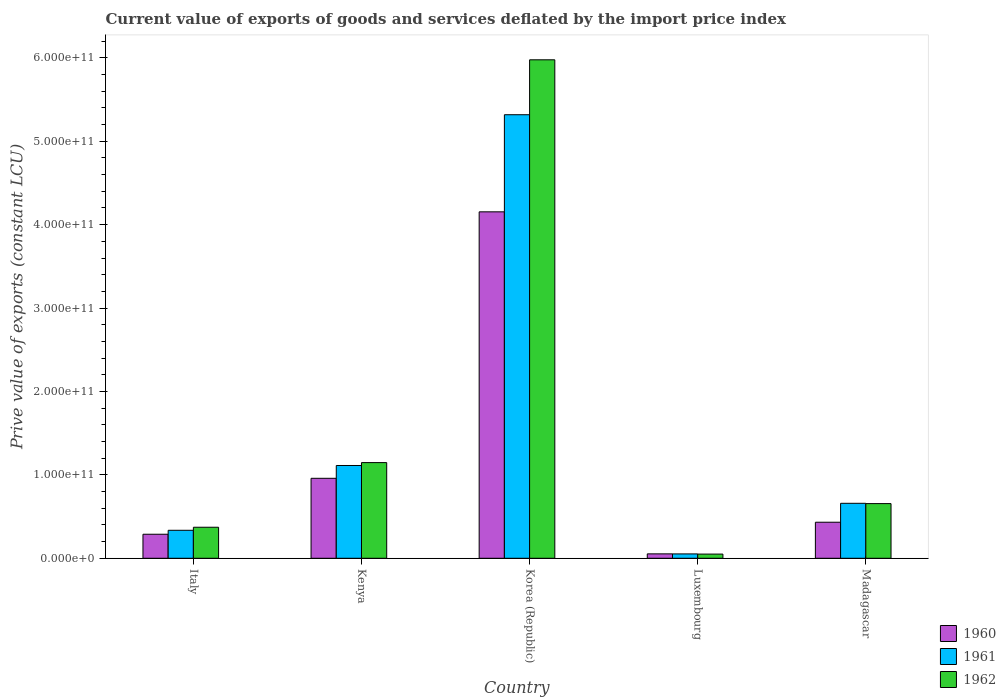How many groups of bars are there?
Offer a terse response. 5. Are the number of bars per tick equal to the number of legend labels?
Ensure brevity in your answer.  Yes. Are the number of bars on each tick of the X-axis equal?
Keep it short and to the point. Yes. How many bars are there on the 2nd tick from the left?
Make the answer very short. 3. How many bars are there on the 2nd tick from the right?
Your answer should be compact. 3. In how many cases, is the number of bars for a given country not equal to the number of legend labels?
Provide a short and direct response. 0. What is the prive value of exports in 1960 in Korea (Republic)?
Make the answer very short. 4.15e+11. Across all countries, what is the maximum prive value of exports in 1960?
Your answer should be compact. 4.15e+11. Across all countries, what is the minimum prive value of exports in 1962?
Give a very brief answer. 5.02e+09. In which country was the prive value of exports in 1961 minimum?
Keep it short and to the point. Luxembourg. What is the total prive value of exports in 1962 in the graph?
Make the answer very short. 8.20e+11. What is the difference between the prive value of exports in 1962 in Italy and that in Kenya?
Your answer should be very brief. -7.75e+1. What is the difference between the prive value of exports in 1960 in Korea (Republic) and the prive value of exports in 1962 in Kenya?
Offer a very short reply. 3.01e+11. What is the average prive value of exports in 1962 per country?
Provide a short and direct response. 1.64e+11. What is the difference between the prive value of exports of/in 1962 and prive value of exports of/in 1961 in Italy?
Provide a short and direct response. 3.65e+09. What is the ratio of the prive value of exports in 1962 in Italy to that in Korea (Republic)?
Offer a terse response. 0.06. What is the difference between the highest and the second highest prive value of exports in 1962?
Offer a terse response. -4.92e+1. What is the difference between the highest and the lowest prive value of exports in 1962?
Provide a short and direct response. 5.93e+11. In how many countries, is the prive value of exports in 1962 greater than the average prive value of exports in 1962 taken over all countries?
Your response must be concise. 1. Is the sum of the prive value of exports in 1961 in Italy and Korea (Republic) greater than the maximum prive value of exports in 1960 across all countries?
Keep it short and to the point. Yes. What does the 2nd bar from the right in Luxembourg represents?
Your answer should be compact. 1961. What is the difference between two consecutive major ticks on the Y-axis?
Give a very brief answer. 1.00e+11. Does the graph contain any zero values?
Ensure brevity in your answer.  No. How many legend labels are there?
Provide a short and direct response. 3. What is the title of the graph?
Offer a very short reply. Current value of exports of goods and services deflated by the import price index. What is the label or title of the X-axis?
Ensure brevity in your answer.  Country. What is the label or title of the Y-axis?
Your answer should be compact. Prive value of exports (constant LCU). What is the Prive value of exports (constant LCU) of 1960 in Italy?
Keep it short and to the point. 2.88e+1. What is the Prive value of exports (constant LCU) of 1961 in Italy?
Offer a terse response. 3.35e+1. What is the Prive value of exports (constant LCU) of 1962 in Italy?
Your answer should be compact. 3.72e+1. What is the Prive value of exports (constant LCU) of 1960 in Kenya?
Your answer should be compact. 9.59e+1. What is the Prive value of exports (constant LCU) in 1961 in Kenya?
Offer a very short reply. 1.11e+11. What is the Prive value of exports (constant LCU) in 1962 in Kenya?
Keep it short and to the point. 1.15e+11. What is the Prive value of exports (constant LCU) of 1960 in Korea (Republic)?
Make the answer very short. 4.15e+11. What is the Prive value of exports (constant LCU) in 1961 in Korea (Republic)?
Offer a very short reply. 5.32e+11. What is the Prive value of exports (constant LCU) in 1962 in Korea (Republic)?
Offer a very short reply. 5.98e+11. What is the Prive value of exports (constant LCU) of 1960 in Luxembourg?
Your response must be concise. 5.28e+09. What is the Prive value of exports (constant LCU) in 1961 in Luxembourg?
Offer a terse response. 5.22e+09. What is the Prive value of exports (constant LCU) in 1962 in Luxembourg?
Provide a short and direct response. 5.02e+09. What is the Prive value of exports (constant LCU) of 1960 in Madagascar?
Give a very brief answer. 4.32e+1. What is the Prive value of exports (constant LCU) of 1961 in Madagascar?
Provide a succinct answer. 6.59e+1. What is the Prive value of exports (constant LCU) in 1962 in Madagascar?
Give a very brief answer. 6.55e+1. Across all countries, what is the maximum Prive value of exports (constant LCU) of 1960?
Offer a terse response. 4.15e+11. Across all countries, what is the maximum Prive value of exports (constant LCU) of 1961?
Make the answer very short. 5.32e+11. Across all countries, what is the maximum Prive value of exports (constant LCU) in 1962?
Give a very brief answer. 5.98e+11. Across all countries, what is the minimum Prive value of exports (constant LCU) in 1960?
Your response must be concise. 5.28e+09. Across all countries, what is the minimum Prive value of exports (constant LCU) of 1961?
Provide a short and direct response. 5.22e+09. Across all countries, what is the minimum Prive value of exports (constant LCU) of 1962?
Provide a succinct answer. 5.02e+09. What is the total Prive value of exports (constant LCU) of 1960 in the graph?
Ensure brevity in your answer.  5.89e+11. What is the total Prive value of exports (constant LCU) of 1961 in the graph?
Your answer should be compact. 7.48e+11. What is the total Prive value of exports (constant LCU) of 1962 in the graph?
Your answer should be very brief. 8.20e+11. What is the difference between the Prive value of exports (constant LCU) of 1960 in Italy and that in Kenya?
Offer a very short reply. -6.71e+1. What is the difference between the Prive value of exports (constant LCU) in 1961 in Italy and that in Kenya?
Make the answer very short. -7.77e+1. What is the difference between the Prive value of exports (constant LCU) in 1962 in Italy and that in Kenya?
Keep it short and to the point. -7.75e+1. What is the difference between the Prive value of exports (constant LCU) in 1960 in Italy and that in Korea (Republic)?
Ensure brevity in your answer.  -3.87e+11. What is the difference between the Prive value of exports (constant LCU) of 1961 in Italy and that in Korea (Republic)?
Offer a terse response. -4.98e+11. What is the difference between the Prive value of exports (constant LCU) in 1962 in Italy and that in Korea (Republic)?
Your answer should be very brief. -5.60e+11. What is the difference between the Prive value of exports (constant LCU) in 1960 in Italy and that in Luxembourg?
Offer a very short reply. 2.35e+1. What is the difference between the Prive value of exports (constant LCU) of 1961 in Italy and that in Luxembourg?
Your answer should be very brief. 2.83e+1. What is the difference between the Prive value of exports (constant LCU) of 1962 in Italy and that in Luxembourg?
Ensure brevity in your answer.  3.22e+1. What is the difference between the Prive value of exports (constant LCU) in 1960 in Italy and that in Madagascar?
Your response must be concise. -1.44e+1. What is the difference between the Prive value of exports (constant LCU) of 1961 in Italy and that in Madagascar?
Your answer should be very brief. -3.24e+1. What is the difference between the Prive value of exports (constant LCU) in 1962 in Italy and that in Madagascar?
Give a very brief answer. -2.84e+1. What is the difference between the Prive value of exports (constant LCU) in 1960 in Kenya and that in Korea (Republic)?
Offer a very short reply. -3.19e+11. What is the difference between the Prive value of exports (constant LCU) in 1961 in Kenya and that in Korea (Republic)?
Your answer should be compact. -4.21e+11. What is the difference between the Prive value of exports (constant LCU) in 1962 in Kenya and that in Korea (Republic)?
Provide a succinct answer. -4.83e+11. What is the difference between the Prive value of exports (constant LCU) in 1960 in Kenya and that in Luxembourg?
Your answer should be very brief. 9.06e+1. What is the difference between the Prive value of exports (constant LCU) of 1961 in Kenya and that in Luxembourg?
Your answer should be very brief. 1.06e+11. What is the difference between the Prive value of exports (constant LCU) in 1962 in Kenya and that in Luxembourg?
Your response must be concise. 1.10e+11. What is the difference between the Prive value of exports (constant LCU) in 1960 in Kenya and that in Madagascar?
Make the answer very short. 5.27e+1. What is the difference between the Prive value of exports (constant LCU) in 1961 in Kenya and that in Madagascar?
Your answer should be compact. 4.53e+1. What is the difference between the Prive value of exports (constant LCU) in 1962 in Kenya and that in Madagascar?
Ensure brevity in your answer.  4.92e+1. What is the difference between the Prive value of exports (constant LCU) of 1960 in Korea (Republic) and that in Luxembourg?
Your answer should be compact. 4.10e+11. What is the difference between the Prive value of exports (constant LCU) in 1961 in Korea (Republic) and that in Luxembourg?
Your response must be concise. 5.27e+11. What is the difference between the Prive value of exports (constant LCU) in 1962 in Korea (Republic) and that in Luxembourg?
Offer a terse response. 5.93e+11. What is the difference between the Prive value of exports (constant LCU) in 1960 in Korea (Republic) and that in Madagascar?
Provide a succinct answer. 3.72e+11. What is the difference between the Prive value of exports (constant LCU) of 1961 in Korea (Republic) and that in Madagascar?
Offer a very short reply. 4.66e+11. What is the difference between the Prive value of exports (constant LCU) of 1962 in Korea (Republic) and that in Madagascar?
Offer a terse response. 5.32e+11. What is the difference between the Prive value of exports (constant LCU) in 1960 in Luxembourg and that in Madagascar?
Your response must be concise. -3.79e+1. What is the difference between the Prive value of exports (constant LCU) of 1961 in Luxembourg and that in Madagascar?
Your response must be concise. -6.07e+1. What is the difference between the Prive value of exports (constant LCU) in 1962 in Luxembourg and that in Madagascar?
Ensure brevity in your answer.  -6.05e+1. What is the difference between the Prive value of exports (constant LCU) of 1960 in Italy and the Prive value of exports (constant LCU) of 1961 in Kenya?
Keep it short and to the point. -8.24e+1. What is the difference between the Prive value of exports (constant LCU) of 1960 in Italy and the Prive value of exports (constant LCU) of 1962 in Kenya?
Your answer should be very brief. -8.59e+1. What is the difference between the Prive value of exports (constant LCU) of 1961 in Italy and the Prive value of exports (constant LCU) of 1962 in Kenya?
Your response must be concise. -8.12e+1. What is the difference between the Prive value of exports (constant LCU) in 1960 in Italy and the Prive value of exports (constant LCU) in 1961 in Korea (Republic)?
Ensure brevity in your answer.  -5.03e+11. What is the difference between the Prive value of exports (constant LCU) in 1960 in Italy and the Prive value of exports (constant LCU) in 1962 in Korea (Republic)?
Offer a terse response. -5.69e+11. What is the difference between the Prive value of exports (constant LCU) in 1961 in Italy and the Prive value of exports (constant LCU) in 1962 in Korea (Republic)?
Make the answer very short. -5.64e+11. What is the difference between the Prive value of exports (constant LCU) in 1960 in Italy and the Prive value of exports (constant LCU) in 1961 in Luxembourg?
Provide a short and direct response. 2.36e+1. What is the difference between the Prive value of exports (constant LCU) of 1960 in Italy and the Prive value of exports (constant LCU) of 1962 in Luxembourg?
Your response must be concise. 2.38e+1. What is the difference between the Prive value of exports (constant LCU) of 1961 in Italy and the Prive value of exports (constant LCU) of 1962 in Luxembourg?
Offer a terse response. 2.85e+1. What is the difference between the Prive value of exports (constant LCU) in 1960 in Italy and the Prive value of exports (constant LCU) in 1961 in Madagascar?
Your answer should be very brief. -3.71e+1. What is the difference between the Prive value of exports (constant LCU) in 1960 in Italy and the Prive value of exports (constant LCU) in 1962 in Madagascar?
Offer a terse response. -3.67e+1. What is the difference between the Prive value of exports (constant LCU) in 1961 in Italy and the Prive value of exports (constant LCU) in 1962 in Madagascar?
Provide a short and direct response. -3.20e+1. What is the difference between the Prive value of exports (constant LCU) in 1960 in Kenya and the Prive value of exports (constant LCU) in 1961 in Korea (Republic)?
Ensure brevity in your answer.  -4.36e+11. What is the difference between the Prive value of exports (constant LCU) of 1960 in Kenya and the Prive value of exports (constant LCU) of 1962 in Korea (Republic)?
Make the answer very short. -5.02e+11. What is the difference between the Prive value of exports (constant LCU) in 1961 in Kenya and the Prive value of exports (constant LCU) in 1962 in Korea (Republic)?
Your response must be concise. -4.86e+11. What is the difference between the Prive value of exports (constant LCU) in 1960 in Kenya and the Prive value of exports (constant LCU) in 1961 in Luxembourg?
Give a very brief answer. 9.07e+1. What is the difference between the Prive value of exports (constant LCU) of 1960 in Kenya and the Prive value of exports (constant LCU) of 1962 in Luxembourg?
Give a very brief answer. 9.09e+1. What is the difference between the Prive value of exports (constant LCU) of 1961 in Kenya and the Prive value of exports (constant LCU) of 1962 in Luxembourg?
Keep it short and to the point. 1.06e+11. What is the difference between the Prive value of exports (constant LCU) in 1960 in Kenya and the Prive value of exports (constant LCU) in 1961 in Madagascar?
Provide a succinct answer. 3.00e+1. What is the difference between the Prive value of exports (constant LCU) of 1960 in Kenya and the Prive value of exports (constant LCU) of 1962 in Madagascar?
Keep it short and to the point. 3.03e+1. What is the difference between the Prive value of exports (constant LCU) of 1961 in Kenya and the Prive value of exports (constant LCU) of 1962 in Madagascar?
Give a very brief answer. 4.57e+1. What is the difference between the Prive value of exports (constant LCU) of 1960 in Korea (Republic) and the Prive value of exports (constant LCU) of 1961 in Luxembourg?
Provide a short and direct response. 4.10e+11. What is the difference between the Prive value of exports (constant LCU) of 1960 in Korea (Republic) and the Prive value of exports (constant LCU) of 1962 in Luxembourg?
Make the answer very short. 4.10e+11. What is the difference between the Prive value of exports (constant LCU) of 1961 in Korea (Republic) and the Prive value of exports (constant LCU) of 1962 in Luxembourg?
Make the answer very short. 5.27e+11. What is the difference between the Prive value of exports (constant LCU) in 1960 in Korea (Republic) and the Prive value of exports (constant LCU) in 1961 in Madagascar?
Your answer should be compact. 3.49e+11. What is the difference between the Prive value of exports (constant LCU) in 1960 in Korea (Republic) and the Prive value of exports (constant LCU) in 1962 in Madagascar?
Provide a succinct answer. 3.50e+11. What is the difference between the Prive value of exports (constant LCU) in 1961 in Korea (Republic) and the Prive value of exports (constant LCU) in 1962 in Madagascar?
Offer a terse response. 4.66e+11. What is the difference between the Prive value of exports (constant LCU) in 1960 in Luxembourg and the Prive value of exports (constant LCU) in 1961 in Madagascar?
Ensure brevity in your answer.  -6.06e+1. What is the difference between the Prive value of exports (constant LCU) of 1960 in Luxembourg and the Prive value of exports (constant LCU) of 1962 in Madagascar?
Your answer should be very brief. -6.03e+1. What is the difference between the Prive value of exports (constant LCU) of 1961 in Luxembourg and the Prive value of exports (constant LCU) of 1962 in Madagascar?
Provide a short and direct response. -6.03e+1. What is the average Prive value of exports (constant LCU) in 1960 per country?
Your response must be concise. 1.18e+11. What is the average Prive value of exports (constant LCU) of 1961 per country?
Offer a very short reply. 1.50e+11. What is the average Prive value of exports (constant LCU) in 1962 per country?
Offer a terse response. 1.64e+11. What is the difference between the Prive value of exports (constant LCU) of 1960 and Prive value of exports (constant LCU) of 1961 in Italy?
Offer a very short reply. -4.73e+09. What is the difference between the Prive value of exports (constant LCU) of 1960 and Prive value of exports (constant LCU) of 1962 in Italy?
Make the answer very short. -8.38e+09. What is the difference between the Prive value of exports (constant LCU) in 1961 and Prive value of exports (constant LCU) in 1962 in Italy?
Your answer should be compact. -3.65e+09. What is the difference between the Prive value of exports (constant LCU) of 1960 and Prive value of exports (constant LCU) of 1961 in Kenya?
Your answer should be compact. -1.54e+1. What is the difference between the Prive value of exports (constant LCU) in 1960 and Prive value of exports (constant LCU) in 1962 in Kenya?
Your response must be concise. -1.88e+1. What is the difference between the Prive value of exports (constant LCU) in 1961 and Prive value of exports (constant LCU) in 1962 in Kenya?
Provide a short and direct response. -3.47e+09. What is the difference between the Prive value of exports (constant LCU) in 1960 and Prive value of exports (constant LCU) in 1961 in Korea (Republic)?
Keep it short and to the point. -1.16e+11. What is the difference between the Prive value of exports (constant LCU) in 1960 and Prive value of exports (constant LCU) in 1962 in Korea (Republic)?
Ensure brevity in your answer.  -1.82e+11. What is the difference between the Prive value of exports (constant LCU) of 1961 and Prive value of exports (constant LCU) of 1962 in Korea (Republic)?
Ensure brevity in your answer.  -6.59e+1. What is the difference between the Prive value of exports (constant LCU) of 1960 and Prive value of exports (constant LCU) of 1961 in Luxembourg?
Your answer should be very brief. 5.55e+07. What is the difference between the Prive value of exports (constant LCU) of 1960 and Prive value of exports (constant LCU) of 1962 in Luxembourg?
Your answer should be very brief. 2.64e+08. What is the difference between the Prive value of exports (constant LCU) in 1961 and Prive value of exports (constant LCU) in 1962 in Luxembourg?
Provide a short and direct response. 2.08e+08. What is the difference between the Prive value of exports (constant LCU) of 1960 and Prive value of exports (constant LCU) of 1961 in Madagascar?
Keep it short and to the point. -2.27e+1. What is the difference between the Prive value of exports (constant LCU) of 1960 and Prive value of exports (constant LCU) of 1962 in Madagascar?
Provide a succinct answer. -2.23e+1. What is the difference between the Prive value of exports (constant LCU) of 1961 and Prive value of exports (constant LCU) of 1962 in Madagascar?
Your answer should be very brief. 3.52e+08. What is the ratio of the Prive value of exports (constant LCU) of 1960 in Italy to that in Kenya?
Keep it short and to the point. 0.3. What is the ratio of the Prive value of exports (constant LCU) in 1961 in Italy to that in Kenya?
Make the answer very short. 0.3. What is the ratio of the Prive value of exports (constant LCU) in 1962 in Italy to that in Kenya?
Provide a succinct answer. 0.32. What is the ratio of the Prive value of exports (constant LCU) in 1960 in Italy to that in Korea (Republic)?
Your answer should be very brief. 0.07. What is the ratio of the Prive value of exports (constant LCU) in 1961 in Italy to that in Korea (Republic)?
Provide a short and direct response. 0.06. What is the ratio of the Prive value of exports (constant LCU) in 1962 in Italy to that in Korea (Republic)?
Your answer should be compact. 0.06. What is the ratio of the Prive value of exports (constant LCU) in 1960 in Italy to that in Luxembourg?
Ensure brevity in your answer.  5.46. What is the ratio of the Prive value of exports (constant LCU) in 1961 in Italy to that in Luxembourg?
Offer a very short reply. 6.42. What is the ratio of the Prive value of exports (constant LCU) of 1962 in Italy to that in Luxembourg?
Keep it short and to the point. 7.42. What is the ratio of the Prive value of exports (constant LCU) of 1960 in Italy to that in Madagascar?
Give a very brief answer. 0.67. What is the ratio of the Prive value of exports (constant LCU) in 1961 in Italy to that in Madagascar?
Give a very brief answer. 0.51. What is the ratio of the Prive value of exports (constant LCU) of 1962 in Italy to that in Madagascar?
Ensure brevity in your answer.  0.57. What is the ratio of the Prive value of exports (constant LCU) of 1960 in Kenya to that in Korea (Republic)?
Your response must be concise. 0.23. What is the ratio of the Prive value of exports (constant LCU) in 1961 in Kenya to that in Korea (Republic)?
Your response must be concise. 0.21. What is the ratio of the Prive value of exports (constant LCU) of 1962 in Kenya to that in Korea (Republic)?
Your response must be concise. 0.19. What is the ratio of the Prive value of exports (constant LCU) of 1960 in Kenya to that in Luxembourg?
Keep it short and to the point. 18.16. What is the ratio of the Prive value of exports (constant LCU) of 1961 in Kenya to that in Luxembourg?
Give a very brief answer. 21.29. What is the ratio of the Prive value of exports (constant LCU) in 1962 in Kenya to that in Luxembourg?
Provide a succinct answer. 22.87. What is the ratio of the Prive value of exports (constant LCU) of 1960 in Kenya to that in Madagascar?
Make the answer very short. 2.22. What is the ratio of the Prive value of exports (constant LCU) of 1961 in Kenya to that in Madagascar?
Offer a very short reply. 1.69. What is the ratio of the Prive value of exports (constant LCU) in 1962 in Kenya to that in Madagascar?
Make the answer very short. 1.75. What is the ratio of the Prive value of exports (constant LCU) in 1960 in Korea (Republic) to that in Luxembourg?
Your response must be concise. 78.67. What is the ratio of the Prive value of exports (constant LCU) of 1961 in Korea (Republic) to that in Luxembourg?
Offer a very short reply. 101.79. What is the ratio of the Prive value of exports (constant LCU) in 1962 in Korea (Republic) to that in Luxembourg?
Your answer should be compact. 119.15. What is the ratio of the Prive value of exports (constant LCU) in 1960 in Korea (Republic) to that in Madagascar?
Provide a short and direct response. 9.61. What is the ratio of the Prive value of exports (constant LCU) in 1961 in Korea (Republic) to that in Madagascar?
Give a very brief answer. 8.07. What is the ratio of the Prive value of exports (constant LCU) of 1962 in Korea (Republic) to that in Madagascar?
Ensure brevity in your answer.  9.12. What is the ratio of the Prive value of exports (constant LCU) in 1960 in Luxembourg to that in Madagascar?
Make the answer very short. 0.12. What is the ratio of the Prive value of exports (constant LCU) of 1961 in Luxembourg to that in Madagascar?
Your answer should be very brief. 0.08. What is the ratio of the Prive value of exports (constant LCU) in 1962 in Luxembourg to that in Madagascar?
Make the answer very short. 0.08. What is the difference between the highest and the second highest Prive value of exports (constant LCU) of 1960?
Make the answer very short. 3.19e+11. What is the difference between the highest and the second highest Prive value of exports (constant LCU) in 1961?
Give a very brief answer. 4.21e+11. What is the difference between the highest and the second highest Prive value of exports (constant LCU) in 1962?
Offer a terse response. 4.83e+11. What is the difference between the highest and the lowest Prive value of exports (constant LCU) of 1960?
Ensure brevity in your answer.  4.10e+11. What is the difference between the highest and the lowest Prive value of exports (constant LCU) of 1961?
Offer a terse response. 5.27e+11. What is the difference between the highest and the lowest Prive value of exports (constant LCU) in 1962?
Give a very brief answer. 5.93e+11. 